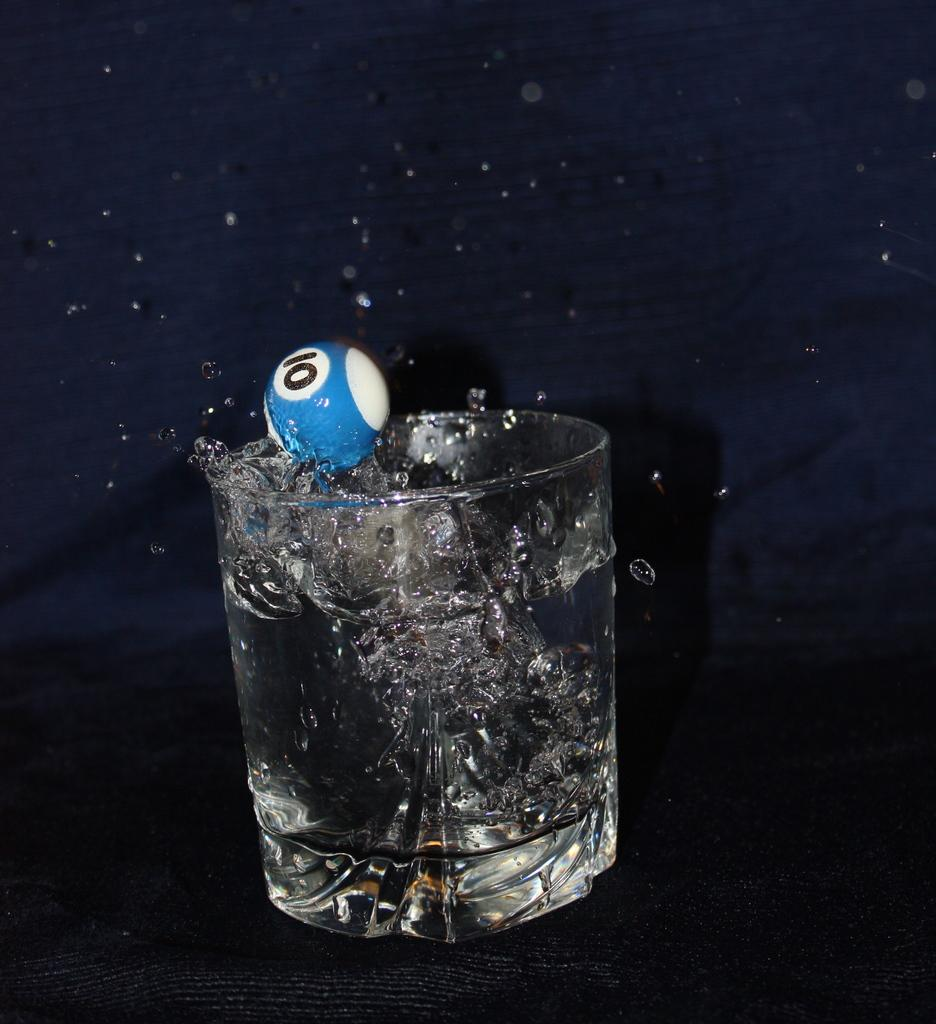What object is bouncing back in the image? There is a small ball in the image that is bouncing back. What else can be seen in the image besides the bouncing ball? There is a glass of water in the image. Where is the glass of water located? The glass of water is on a table. What type of support is the small ball using to bounce back? The small ball does not use any specific support to bounce back; it is bouncing off the surface it is in contact with. How is the glass of water being held together in the image? The glass of water is not being held together by glue; it is a typical glass filled with water. 